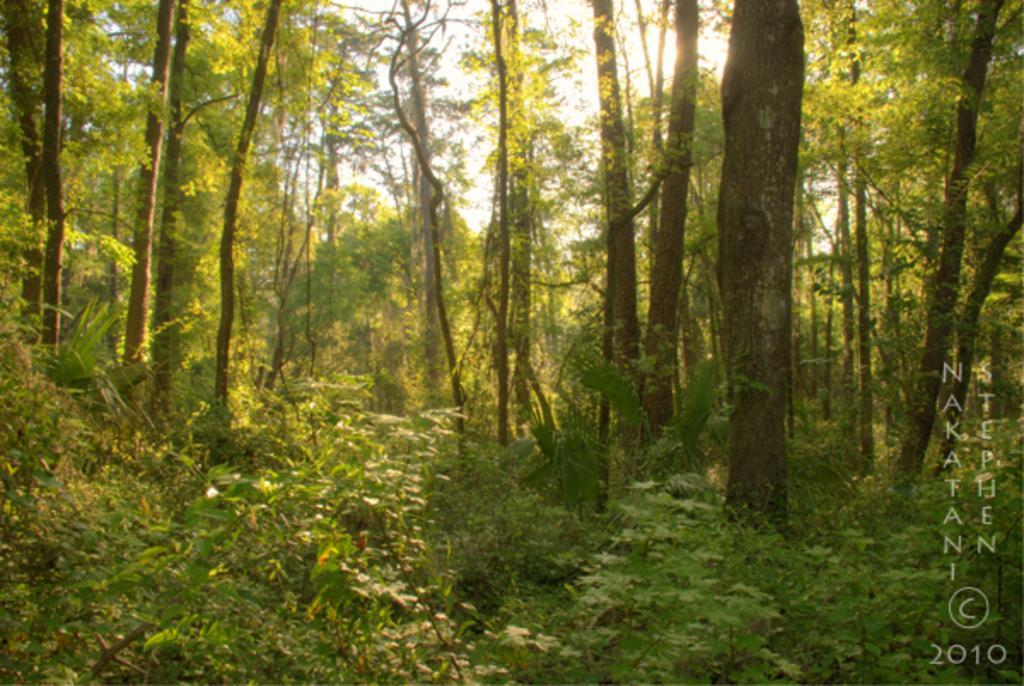In one or two sentences, can you explain what this image depicts? In the image we can see there are plants on the ground and there are lot of trees. 